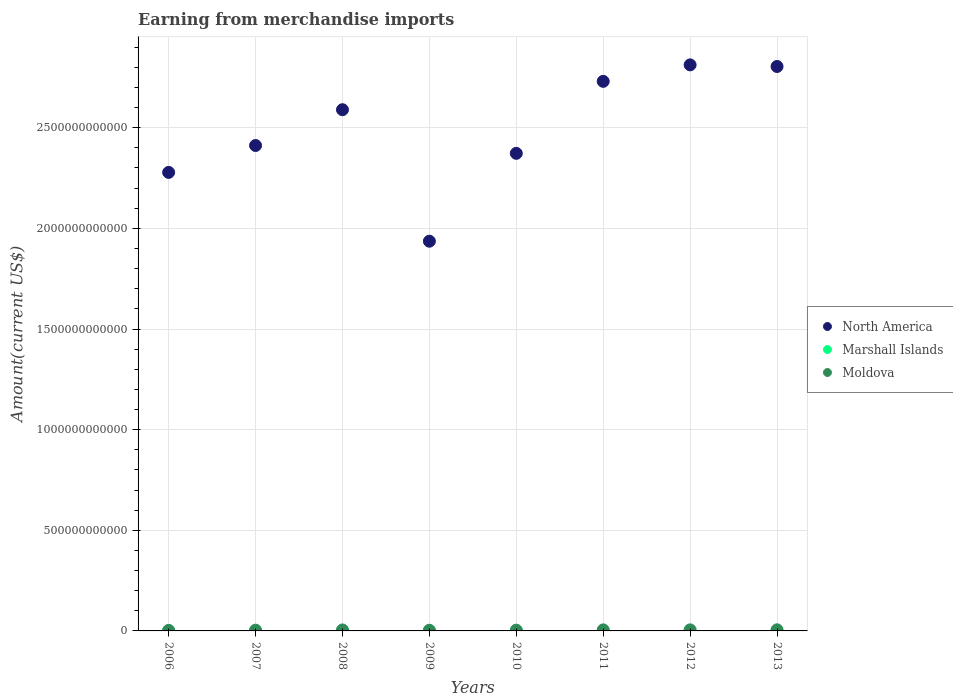What is the amount earned from merchandise imports in Moldova in 2008?
Your answer should be compact. 4.90e+09. Across all years, what is the maximum amount earned from merchandise imports in Marshall Islands?
Your answer should be compact. 1.50e+08. Across all years, what is the minimum amount earned from merchandise imports in Moldova?
Ensure brevity in your answer.  2.69e+09. What is the total amount earned from merchandise imports in Marshall Islands in the graph?
Your response must be concise. 9.56e+08. What is the difference between the amount earned from merchandise imports in Marshall Islands in 2006 and that in 2007?
Make the answer very short. -9.00e+06. What is the difference between the amount earned from merchandise imports in North America in 2010 and the amount earned from merchandise imports in Moldova in 2008?
Offer a terse response. 2.37e+12. What is the average amount earned from merchandise imports in Marshall Islands per year?
Keep it short and to the point. 1.20e+08. In the year 2009, what is the difference between the amount earned from merchandise imports in North America and amount earned from merchandise imports in Marshall Islands?
Offer a very short reply. 1.94e+12. What is the ratio of the amount earned from merchandise imports in North America in 2012 to that in 2013?
Your response must be concise. 1. Is the amount earned from merchandise imports in Marshall Islands in 2007 less than that in 2010?
Your answer should be very brief. Yes. What is the difference between the highest and the second highest amount earned from merchandise imports in North America?
Ensure brevity in your answer.  7.99e+09. What is the difference between the highest and the lowest amount earned from merchandise imports in Moldova?
Your response must be concise. 2.80e+09. Is it the case that in every year, the sum of the amount earned from merchandise imports in North America and amount earned from merchandise imports in Moldova  is greater than the amount earned from merchandise imports in Marshall Islands?
Your answer should be compact. Yes. Is the amount earned from merchandise imports in Moldova strictly greater than the amount earned from merchandise imports in North America over the years?
Ensure brevity in your answer.  No. Is the amount earned from merchandise imports in Moldova strictly less than the amount earned from merchandise imports in North America over the years?
Ensure brevity in your answer.  Yes. How many dotlines are there?
Offer a very short reply. 3. What is the difference between two consecutive major ticks on the Y-axis?
Ensure brevity in your answer.  5.00e+11. Does the graph contain any zero values?
Your answer should be very brief. No. Does the graph contain grids?
Offer a terse response. Yes. Where does the legend appear in the graph?
Ensure brevity in your answer.  Center right. How many legend labels are there?
Keep it short and to the point. 3. How are the legend labels stacked?
Give a very brief answer. Vertical. What is the title of the graph?
Make the answer very short. Earning from merchandise imports. Does "Italy" appear as one of the legend labels in the graph?
Offer a very short reply. No. What is the label or title of the X-axis?
Provide a short and direct response. Years. What is the label or title of the Y-axis?
Your answer should be very brief. Amount(current US$). What is the Amount(current US$) of North America in 2006?
Provide a short and direct response. 2.28e+12. What is the Amount(current US$) in Marshall Islands in 2006?
Provide a short and direct response. 9.10e+07. What is the Amount(current US$) in Moldova in 2006?
Keep it short and to the point. 2.69e+09. What is the Amount(current US$) of North America in 2007?
Your answer should be very brief. 2.41e+12. What is the Amount(current US$) of Marshall Islands in 2007?
Ensure brevity in your answer.  1.00e+08. What is the Amount(current US$) of Moldova in 2007?
Make the answer very short. 3.69e+09. What is the Amount(current US$) of North America in 2008?
Provide a short and direct response. 2.59e+12. What is the Amount(current US$) in Moldova in 2008?
Provide a short and direct response. 4.90e+09. What is the Amount(current US$) of North America in 2009?
Your response must be concise. 1.94e+12. What is the Amount(current US$) in Marshall Islands in 2009?
Your answer should be compact. 1.05e+08. What is the Amount(current US$) of Moldova in 2009?
Give a very brief answer. 3.28e+09. What is the Amount(current US$) in North America in 2010?
Provide a short and direct response. 2.37e+12. What is the Amount(current US$) in Marshall Islands in 2010?
Your answer should be very brief. 1.50e+08. What is the Amount(current US$) of Moldova in 2010?
Provide a short and direct response. 3.86e+09. What is the Amount(current US$) in North America in 2011?
Provide a short and direct response. 2.73e+12. What is the Amount(current US$) of Marshall Islands in 2011?
Keep it short and to the point. 1.30e+08. What is the Amount(current US$) of Moldova in 2011?
Make the answer very short. 5.19e+09. What is the Amount(current US$) in North America in 2012?
Offer a terse response. 2.81e+12. What is the Amount(current US$) of Marshall Islands in 2012?
Provide a short and direct response. 1.40e+08. What is the Amount(current US$) of Moldova in 2012?
Provide a succinct answer. 5.21e+09. What is the Amount(current US$) of North America in 2013?
Offer a very short reply. 2.80e+12. What is the Amount(current US$) in Marshall Islands in 2013?
Offer a very short reply. 1.40e+08. What is the Amount(current US$) in Moldova in 2013?
Provide a short and direct response. 5.49e+09. Across all years, what is the maximum Amount(current US$) in North America?
Offer a terse response. 2.81e+12. Across all years, what is the maximum Amount(current US$) of Marshall Islands?
Keep it short and to the point. 1.50e+08. Across all years, what is the maximum Amount(current US$) of Moldova?
Ensure brevity in your answer.  5.49e+09. Across all years, what is the minimum Amount(current US$) of North America?
Your response must be concise. 1.94e+12. Across all years, what is the minimum Amount(current US$) of Marshall Islands?
Provide a short and direct response. 9.10e+07. Across all years, what is the minimum Amount(current US$) of Moldova?
Offer a very short reply. 2.69e+09. What is the total Amount(current US$) of North America in the graph?
Provide a short and direct response. 1.99e+13. What is the total Amount(current US$) in Marshall Islands in the graph?
Make the answer very short. 9.56e+08. What is the total Amount(current US$) of Moldova in the graph?
Your response must be concise. 3.43e+1. What is the difference between the Amount(current US$) of North America in 2006 and that in 2007?
Your answer should be very brief. -1.34e+11. What is the difference between the Amount(current US$) in Marshall Islands in 2006 and that in 2007?
Make the answer very short. -9.00e+06. What is the difference between the Amount(current US$) in Moldova in 2006 and that in 2007?
Make the answer very short. -9.97e+08. What is the difference between the Amount(current US$) in North America in 2006 and that in 2008?
Your answer should be very brief. -3.11e+11. What is the difference between the Amount(current US$) of Marshall Islands in 2006 and that in 2008?
Offer a very short reply. -9.00e+06. What is the difference between the Amount(current US$) in Moldova in 2006 and that in 2008?
Make the answer very short. -2.21e+09. What is the difference between the Amount(current US$) in North America in 2006 and that in 2009?
Offer a terse response. 3.42e+11. What is the difference between the Amount(current US$) in Marshall Islands in 2006 and that in 2009?
Your response must be concise. -1.40e+07. What is the difference between the Amount(current US$) of Moldova in 2006 and that in 2009?
Give a very brief answer. -5.85e+08. What is the difference between the Amount(current US$) of North America in 2006 and that in 2010?
Your answer should be very brief. -9.47e+1. What is the difference between the Amount(current US$) in Marshall Islands in 2006 and that in 2010?
Provide a succinct answer. -5.90e+07. What is the difference between the Amount(current US$) in Moldova in 2006 and that in 2010?
Provide a short and direct response. -1.16e+09. What is the difference between the Amount(current US$) in North America in 2006 and that in 2011?
Offer a terse response. -4.52e+11. What is the difference between the Amount(current US$) of Marshall Islands in 2006 and that in 2011?
Offer a terse response. -3.90e+07. What is the difference between the Amount(current US$) of Moldova in 2006 and that in 2011?
Ensure brevity in your answer.  -2.50e+09. What is the difference between the Amount(current US$) of North America in 2006 and that in 2012?
Keep it short and to the point. -5.34e+11. What is the difference between the Amount(current US$) of Marshall Islands in 2006 and that in 2012?
Make the answer very short. -4.90e+07. What is the difference between the Amount(current US$) of Moldova in 2006 and that in 2012?
Offer a very short reply. -2.52e+09. What is the difference between the Amount(current US$) in North America in 2006 and that in 2013?
Offer a very short reply. -5.26e+11. What is the difference between the Amount(current US$) of Marshall Islands in 2006 and that in 2013?
Keep it short and to the point. -4.90e+07. What is the difference between the Amount(current US$) in Moldova in 2006 and that in 2013?
Your response must be concise. -2.80e+09. What is the difference between the Amount(current US$) of North America in 2007 and that in 2008?
Provide a succinct answer. -1.78e+11. What is the difference between the Amount(current US$) of Marshall Islands in 2007 and that in 2008?
Your response must be concise. 0. What is the difference between the Amount(current US$) of Moldova in 2007 and that in 2008?
Provide a short and direct response. -1.21e+09. What is the difference between the Amount(current US$) of North America in 2007 and that in 2009?
Your answer should be very brief. 4.75e+11. What is the difference between the Amount(current US$) in Marshall Islands in 2007 and that in 2009?
Give a very brief answer. -5.00e+06. What is the difference between the Amount(current US$) of Moldova in 2007 and that in 2009?
Your answer should be very brief. 4.12e+08. What is the difference between the Amount(current US$) of North America in 2007 and that in 2010?
Provide a short and direct response. 3.89e+1. What is the difference between the Amount(current US$) in Marshall Islands in 2007 and that in 2010?
Provide a succinct answer. -5.00e+07. What is the difference between the Amount(current US$) of Moldova in 2007 and that in 2010?
Offer a very short reply. -1.65e+08. What is the difference between the Amount(current US$) of North America in 2007 and that in 2011?
Make the answer very short. -3.19e+11. What is the difference between the Amount(current US$) in Marshall Islands in 2007 and that in 2011?
Offer a terse response. -3.00e+07. What is the difference between the Amount(current US$) of Moldova in 2007 and that in 2011?
Give a very brief answer. -1.50e+09. What is the difference between the Amount(current US$) of North America in 2007 and that in 2012?
Provide a short and direct response. -4.01e+11. What is the difference between the Amount(current US$) of Marshall Islands in 2007 and that in 2012?
Keep it short and to the point. -4.00e+07. What is the difference between the Amount(current US$) in Moldova in 2007 and that in 2012?
Offer a very short reply. -1.52e+09. What is the difference between the Amount(current US$) in North America in 2007 and that in 2013?
Keep it short and to the point. -3.93e+11. What is the difference between the Amount(current US$) of Marshall Islands in 2007 and that in 2013?
Make the answer very short. -4.00e+07. What is the difference between the Amount(current US$) of Moldova in 2007 and that in 2013?
Provide a succinct answer. -1.80e+09. What is the difference between the Amount(current US$) in North America in 2008 and that in 2009?
Your answer should be compact. 6.53e+11. What is the difference between the Amount(current US$) of Marshall Islands in 2008 and that in 2009?
Keep it short and to the point. -5.00e+06. What is the difference between the Amount(current US$) of Moldova in 2008 and that in 2009?
Offer a very short reply. 1.62e+09. What is the difference between the Amount(current US$) in North America in 2008 and that in 2010?
Your answer should be very brief. 2.17e+11. What is the difference between the Amount(current US$) of Marshall Islands in 2008 and that in 2010?
Offer a very short reply. -5.00e+07. What is the difference between the Amount(current US$) of Moldova in 2008 and that in 2010?
Give a very brief answer. 1.04e+09. What is the difference between the Amount(current US$) in North America in 2008 and that in 2011?
Keep it short and to the point. -1.41e+11. What is the difference between the Amount(current US$) in Marshall Islands in 2008 and that in 2011?
Provide a short and direct response. -3.00e+07. What is the difference between the Amount(current US$) in Moldova in 2008 and that in 2011?
Keep it short and to the point. -2.93e+08. What is the difference between the Amount(current US$) of North America in 2008 and that in 2012?
Give a very brief answer. -2.23e+11. What is the difference between the Amount(current US$) of Marshall Islands in 2008 and that in 2012?
Give a very brief answer. -4.00e+07. What is the difference between the Amount(current US$) of Moldova in 2008 and that in 2012?
Your answer should be compact. -3.14e+08. What is the difference between the Amount(current US$) in North America in 2008 and that in 2013?
Your answer should be compact. -2.15e+11. What is the difference between the Amount(current US$) of Marshall Islands in 2008 and that in 2013?
Your response must be concise. -4.00e+07. What is the difference between the Amount(current US$) in Moldova in 2008 and that in 2013?
Provide a succinct answer. -5.94e+08. What is the difference between the Amount(current US$) of North America in 2009 and that in 2010?
Offer a very short reply. -4.37e+11. What is the difference between the Amount(current US$) in Marshall Islands in 2009 and that in 2010?
Ensure brevity in your answer.  -4.50e+07. What is the difference between the Amount(current US$) of Moldova in 2009 and that in 2010?
Your answer should be very brief. -5.77e+08. What is the difference between the Amount(current US$) in North America in 2009 and that in 2011?
Offer a terse response. -7.94e+11. What is the difference between the Amount(current US$) of Marshall Islands in 2009 and that in 2011?
Offer a very short reply. -2.50e+07. What is the difference between the Amount(current US$) in Moldova in 2009 and that in 2011?
Your response must be concise. -1.91e+09. What is the difference between the Amount(current US$) of North America in 2009 and that in 2012?
Make the answer very short. -8.76e+11. What is the difference between the Amount(current US$) in Marshall Islands in 2009 and that in 2012?
Offer a terse response. -3.50e+07. What is the difference between the Amount(current US$) of Moldova in 2009 and that in 2012?
Keep it short and to the point. -1.93e+09. What is the difference between the Amount(current US$) of North America in 2009 and that in 2013?
Provide a succinct answer. -8.68e+11. What is the difference between the Amount(current US$) in Marshall Islands in 2009 and that in 2013?
Your response must be concise. -3.50e+07. What is the difference between the Amount(current US$) of Moldova in 2009 and that in 2013?
Your response must be concise. -2.21e+09. What is the difference between the Amount(current US$) of North America in 2010 and that in 2011?
Keep it short and to the point. -3.58e+11. What is the difference between the Amount(current US$) of Moldova in 2010 and that in 2011?
Your response must be concise. -1.34e+09. What is the difference between the Amount(current US$) in North America in 2010 and that in 2012?
Offer a terse response. -4.40e+11. What is the difference between the Amount(current US$) in Marshall Islands in 2010 and that in 2012?
Offer a very short reply. 1.00e+07. What is the difference between the Amount(current US$) of Moldova in 2010 and that in 2012?
Make the answer very short. -1.36e+09. What is the difference between the Amount(current US$) in North America in 2010 and that in 2013?
Your answer should be very brief. -4.32e+11. What is the difference between the Amount(current US$) of Moldova in 2010 and that in 2013?
Keep it short and to the point. -1.64e+09. What is the difference between the Amount(current US$) in North America in 2011 and that in 2012?
Provide a succinct answer. -8.18e+1. What is the difference between the Amount(current US$) of Marshall Islands in 2011 and that in 2012?
Your response must be concise. -1.00e+07. What is the difference between the Amount(current US$) of Moldova in 2011 and that in 2012?
Provide a succinct answer. -2.16e+07. What is the difference between the Amount(current US$) of North America in 2011 and that in 2013?
Provide a succinct answer. -7.38e+1. What is the difference between the Amount(current US$) of Marshall Islands in 2011 and that in 2013?
Your response must be concise. -1.00e+07. What is the difference between the Amount(current US$) of Moldova in 2011 and that in 2013?
Ensure brevity in your answer.  -3.01e+08. What is the difference between the Amount(current US$) of North America in 2012 and that in 2013?
Your answer should be very brief. 7.99e+09. What is the difference between the Amount(current US$) of Marshall Islands in 2012 and that in 2013?
Offer a terse response. 0. What is the difference between the Amount(current US$) of Moldova in 2012 and that in 2013?
Offer a very short reply. -2.80e+08. What is the difference between the Amount(current US$) in North America in 2006 and the Amount(current US$) in Marshall Islands in 2007?
Offer a terse response. 2.28e+12. What is the difference between the Amount(current US$) of North America in 2006 and the Amount(current US$) of Moldova in 2007?
Your answer should be very brief. 2.27e+12. What is the difference between the Amount(current US$) of Marshall Islands in 2006 and the Amount(current US$) of Moldova in 2007?
Provide a short and direct response. -3.60e+09. What is the difference between the Amount(current US$) in North America in 2006 and the Amount(current US$) in Marshall Islands in 2008?
Your response must be concise. 2.28e+12. What is the difference between the Amount(current US$) of North America in 2006 and the Amount(current US$) of Moldova in 2008?
Your answer should be very brief. 2.27e+12. What is the difference between the Amount(current US$) in Marshall Islands in 2006 and the Amount(current US$) in Moldova in 2008?
Offer a terse response. -4.81e+09. What is the difference between the Amount(current US$) of North America in 2006 and the Amount(current US$) of Marshall Islands in 2009?
Offer a terse response. 2.28e+12. What is the difference between the Amount(current US$) in North America in 2006 and the Amount(current US$) in Moldova in 2009?
Your answer should be very brief. 2.27e+12. What is the difference between the Amount(current US$) in Marshall Islands in 2006 and the Amount(current US$) in Moldova in 2009?
Make the answer very short. -3.19e+09. What is the difference between the Amount(current US$) in North America in 2006 and the Amount(current US$) in Marshall Islands in 2010?
Offer a very short reply. 2.28e+12. What is the difference between the Amount(current US$) of North America in 2006 and the Amount(current US$) of Moldova in 2010?
Make the answer very short. 2.27e+12. What is the difference between the Amount(current US$) in Marshall Islands in 2006 and the Amount(current US$) in Moldova in 2010?
Make the answer very short. -3.76e+09. What is the difference between the Amount(current US$) in North America in 2006 and the Amount(current US$) in Marshall Islands in 2011?
Your answer should be compact. 2.28e+12. What is the difference between the Amount(current US$) in North America in 2006 and the Amount(current US$) in Moldova in 2011?
Ensure brevity in your answer.  2.27e+12. What is the difference between the Amount(current US$) in Marshall Islands in 2006 and the Amount(current US$) in Moldova in 2011?
Offer a terse response. -5.10e+09. What is the difference between the Amount(current US$) in North America in 2006 and the Amount(current US$) in Marshall Islands in 2012?
Provide a short and direct response. 2.28e+12. What is the difference between the Amount(current US$) in North America in 2006 and the Amount(current US$) in Moldova in 2012?
Your answer should be very brief. 2.27e+12. What is the difference between the Amount(current US$) in Marshall Islands in 2006 and the Amount(current US$) in Moldova in 2012?
Keep it short and to the point. -5.12e+09. What is the difference between the Amount(current US$) in North America in 2006 and the Amount(current US$) in Marshall Islands in 2013?
Offer a very short reply. 2.28e+12. What is the difference between the Amount(current US$) in North America in 2006 and the Amount(current US$) in Moldova in 2013?
Your response must be concise. 2.27e+12. What is the difference between the Amount(current US$) of Marshall Islands in 2006 and the Amount(current US$) of Moldova in 2013?
Make the answer very short. -5.40e+09. What is the difference between the Amount(current US$) in North America in 2007 and the Amount(current US$) in Marshall Islands in 2008?
Provide a short and direct response. 2.41e+12. What is the difference between the Amount(current US$) in North America in 2007 and the Amount(current US$) in Moldova in 2008?
Make the answer very short. 2.41e+12. What is the difference between the Amount(current US$) of Marshall Islands in 2007 and the Amount(current US$) of Moldova in 2008?
Your response must be concise. -4.80e+09. What is the difference between the Amount(current US$) in North America in 2007 and the Amount(current US$) in Marshall Islands in 2009?
Your answer should be very brief. 2.41e+12. What is the difference between the Amount(current US$) in North America in 2007 and the Amount(current US$) in Moldova in 2009?
Offer a terse response. 2.41e+12. What is the difference between the Amount(current US$) in Marshall Islands in 2007 and the Amount(current US$) in Moldova in 2009?
Your answer should be compact. -3.18e+09. What is the difference between the Amount(current US$) of North America in 2007 and the Amount(current US$) of Marshall Islands in 2010?
Make the answer very short. 2.41e+12. What is the difference between the Amount(current US$) of North America in 2007 and the Amount(current US$) of Moldova in 2010?
Keep it short and to the point. 2.41e+12. What is the difference between the Amount(current US$) of Marshall Islands in 2007 and the Amount(current US$) of Moldova in 2010?
Offer a terse response. -3.76e+09. What is the difference between the Amount(current US$) of North America in 2007 and the Amount(current US$) of Marshall Islands in 2011?
Give a very brief answer. 2.41e+12. What is the difference between the Amount(current US$) in North America in 2007 and the Amount(current US$) in Moldova in 2011?
Make the answer very short. 2.41e+12. What is the difference between the Amount(current US$) in Marshall Islands in 2007 and the Amount(current US$) in Moldova in 2011?
Provide a short and direct response. -5.09e+09. What is the difference between the Amount(current US$) of North America in 2007 and the Amount(current US$) of Marshall Islands in 2012?
Offer a very short reply. 2.41e+12. What is the difference between the Amount(current US$) in North America in 2007 and the Amount(current US$) in Moldova in 2012?
Give a very brief answer. 2.41e+12. What is the difference between the Amount(current US$) in Marshall Islands in 2007 and the Amount(current US$) in Moldova in 2012?
Offer a very short reply. -5.11e+09. What is the difference between the Amount(current US$) in North America in 2007 and the Amount(current US$) in Marshall Islands in 2013?
Offer a terse response. 2.41e+12. What is the difference between the Amount(current US$) of North America in 2007 and the Amount(current US$) of Moldova in 2013?
Keep it short and to the point. 2.41e+12. What is the difference between the Amount(current US$) of Marshall Islands in 2007 and the Amount(current US$) of Moldova in 2013?
Your response must be concise. -5.39e+09. What is the difference between the Amount(current US$) of North America in 2008 and the Amount(current US$) of Marshall Islands in 2009?
Provide a succinct answer. 2.59e+12. What is the difference between the Amount(current US$) in North America in 2008 and the Amount(current US$) in Moldova in 2009?
Your response must be concise. 2.59e+12. What is the difference between the Amount(current US$) in Marshall Islands in 2008 and the Amount(current US$) in Moldova in 2009?
Give a very brief answer. -3.18e+09. What is the difference between the Amount(current US$) of North America in 2008 and the Amount(current US$) of Marshall Islands in 2010?
Give a very brief answer. 2.59e+12. What is the difference between the Amount(current US$) of North America in 2008 and the Amount(current US$) of Moldova in 2010?
Provide a short and direct response. 2.59e+12. What is the difference between the Amount(current US$) in Marshall Islands in 2008 and the Amount(current US$) in Moldova in 2010?
Your answer should be compact. -3.76e+09. What is the difference between the Amount(current US$) of North America in 2008 and the Amount(current US$) of Marshall Islands in 2011?
Keep it short and to the point. 2.59e+12. What is the difference between the Amount(current US$) in North America in 2008 and the Amount(current US$) in Moldova in 2011?
Offer a very short reply. 2.58e+12. What is the difference between the Amount(current US$) in Marshall Islands in 2008 and the Amount(current US$) in Moldova in 2011?
Provide a short and direct response. -5.09e+09. What is the difference between the Amount(current US$) of North America in 2008 and the Amount(current US$) of Marshall Islands in 2012?
Keep it short and to the point. 2.59e+12. What is the difference between the Amount(current US$) in North America in 2008 and the Amount(current US$) in Moldova in 2012?
Provide a short and direct response. 2.58e+12. What is the difference between the Amount(current US$) of Marshall Islands in 2008 and the Amount(current US$) of Moldova in 2012?
Keep it short and to the point. -5.11e+09. What is the difference between the Amount(current US$) of North America in 2008 and the Amount(current US$) of Marshall Islands in 2013?
Give a very brief answer. 2.59e+12. What is the difference between the Amount(current US$) in North America in 2008 and the Amount(current US$) in Moldova in 2013?
Provide a short and direct response. 2.58e+12. What is the difference between the Amount(current US$) of Marshall Islands in 2008 and the Amount(current US$) of Moldova in 2013?
Give a very brief answer. -5.39e+09. What is the difference between the Amount(current US$) in North America in 2009 and the Amount(current US$) in Marshall Islands in 2010?
Give a very brief answer. 1.94e+12. What is the difference between the Amount(current US$) of North America in 2009 and the Amount(current US$) of Moldova in 2010?
Your response must be concise. 1.93e+12. What is the difference between the Amount(current US$) of Marshall Islands in 2009 and the Amount(current US$) of Moldova in 2010?
Provide a short and direct response. -3.75e+09. What is the difference between the Amount(current US$) of North America in 2009 and the Amount(current US$) of Marshall Islands in 2011?
Offer a very short reply. 1.94e+12. What is the difference between the Amount(current US$) in North America in 2009 and the Amount(current US$) in Moldova in 2011?
Keep it short and to the point. 1.93e+12. What is the difference between the Amount(current US$) in Marshall Islands in 2009 and the Amount(current US$) in Moldova in 2011?
Offer a very short reply. -5.09e+09. What is the difference between the Amount(current US$) in North America in 2009 and the Amount(current US$) in Marshall Islands in 2012?
Make the answer very short. 1.94e+12. What is the difference between the Amount(current US$) in North America in 2009 and the Amount(current US$) in Moldova in 2012?
Offer a terse response. 1.93e+12. What is the difference between the Amount(current US$) of Marshall Islands in 2009 and the Amount(current US$) of Moldova in 2012?
Provide a succinct answer. -5.11e+09. What is the difference between the Amount(current US$) of North America in 2009 and the Amount(current US$) of Marshall Islands in 2013?
Make the answer very short. 1.94e+12. What is the difference between the Amount(current US$) of North America in 2009 and the Amount(current US$) of Moldova in 2013?
Keep it short and to the point. 1.93e+12. What is the difference between the Amount(current US$) in Marshall Islands in 2009 and the Amount(current US$) in Moldova in 2013?
Provide a succinct answer. -5.39e+09. What is the difference between the Amount(current US$) of North America in 2010 and the Amount(current US$) of Marshall Islands in 2011?
Offer a terse response. 2.37e+12. What is the difference between the Amount(current US$) in North America in 2010 and the Amount(current US$) in Moldova in 2011?
Keep it short and to the point. 2.37e+12. What is the difference between the Amount(current US$) in Marshall Islands in 2010 and the Amount(current US$) in Moldova in 2011?
Keep it short and to the point. -5.04e+09. What is the difference between the Amount(current US$) of North America in 2010 and the Amount(current US$) of Marshall Islands in 2012?
Offer a terse response. 2.37e+12. What is the difference between the Amount(current US$) of North America in 2010 and the Amount(current US$) of Moldova in 2012?
Make the answer very short. 2.37e+12. What is the difference between the Amount(current US$) in Marshall Islands in 2010 and the Amount(current US$) in Moldova in 2012?
Your answer should be very brief. -5.06e+09. What is the difference between the Amount(current US$) of North America in 2010 and the Amount(current US$) of Marshall Islands in 2013?
Your answer should be compact. 2.37e+12. What is the difference between the Amount(current US$) in North America in 2010 and the Amount(current US$) in Moldova in 2013?
Make the answer very short. 2.37e+12. What is the difference between the Amount(current US$) of Marshall Islands in 2010 and the Amount(current US$) of Moldova in 2013?
Provide a short and direct response. -5.34e+09. What is the difference between the Amount(current US$) in North America in 2011 and the Amount(current US$) in Marshall Islands in 2012?
Provide a short and direct response. 2.73e+12. What is the difference between the Amount(current US$) in North America in 2011 and the Amount(current US$) in Moldova in 2012?
Offer a very short reply. 2.73e+12. What is the difference between the Amount(current US$) of Marshall Islands in 2011 and the Amount(current US$) of Moldova in 2012?
Your answer should be very brief. -5.08e+09. What is the difference between the Amount(current US$) of North America in 2011 and the Amount(current US$) of Marshall Islands in 2013?
Make the answer very short. 2.73e+12. What is the difference between the Amount(current US$) of North America in 2011 and the Amount(current US$) of Moldova in 2013?
Your answer should be very brief. 2.73e+12. What is the difference between the Amount(current US$) of Marshall Islands in 2011 and the Amount(current US$) of Moldova in 2013?
Your response must be concise. -5.36e+09. What is the difference between the Amount(current US$) of North America in 2012 and the Amount(current US$) of Marshall Islands in 2013?
Make the answer very short. 2.81e+12. What is the difference between the Amount(current US$) of North America in 2012 and the Amount(current US$) of Moldova in 2013?
Ensure brevity in your answer.  2.81e+12. What is the difference between the Amount(current US$) in Marshall Islands in 2012 and the Amount(current US$) in Moldova in 2013?
Provide a short and direct response. -5.35e+09. What is the average Amount(current US$) in North America per year?
Offer a terse response. 2.49e+12. What is the average Amount(current US$) of Marshall Islands per year?
Provide a succinct answer. 1.20e+08. What is the average Amount(current US$) of Moldova per year?
Your answer should be very brief. 4.29e+09. In the year 2006, what is the difference between the Amount(current US$) of North America and Amount(current US$) of Marshall Islands?
Offer a terse response. 2.28e+12. In the year 2006, what is the difference between the Amount(current US$) of North America and Amount(current US$) of Moldova?
Offer a terse response. 2.28e+12. In the year 2006, what is the difference between the Amount(current US$) of Marshall Islands and Amount(current US$) of Moldova?
Offer a very short reply. -2.60e+09. In the year 2007, what is the difference between the Amount(current US$) of North America and Amount(current US$) of Marshall Islands?
Provide a short and direct response. 2.41e+12. In the year 2007, what is the difference between the Amount(current US$) in North America and Amount(current US$) in Moldova?
Ensure brevity in your answer.  2.41e+12. In the year 2007, what is the difference between the Amount(current US$) in Marshall Islands and Amount(current US$) in Moldova?
Provide a short and direct response. -3.59e+09. In the year 2008, what is the difference between the Amount(current US$) in North America and Amount(current US$) in Marshall Islands?
Provide a succinct answer. 2.59e+12. In the year 2008, what is the difference between the Amount(current US$) of North America and Amount(current US$) of Moldova?
Provide a succinct answer. 2.58e+12. In the year 2008, what is the difference between the Amount(current US$) of Marshall Islands and Amount(current US$) of Moldova?
Your response must be concise. -4.80e+09. In the year 2009, what is the difference between the Amount(current US$) in North America and Amount(current US$) in Marshall Islands?
Make the answer very short. 1.94e+12. In the year 2009, what is the difference between the Amount(current US$) of North America and Amount(current US$) of Moldova?
Your answer should be compact. 1.93e+12. In the year 2009, what is the difference between the Amount(current US$) of Marshall Islands and Amount(current US$) of Moldova?
Your answer should be very brief. -3.17e+09. In the year 2010, what is the difference between the Amount(current US$) of North America and Amount(current US$) of Marshall Islands?
Offer a very short reply. 2.37e+12. In the year 2010, what is the difference between the Amount(current US$) of North America and Amount(current US$) of Moldova?
Offer a terse response. 2.37e+12. In the year 2010, what is the difference between the Amount(current US$) of Marshall Islands and Amount(current US$) of Moldova?
Ensure brevity in your answer.  -3.71e+09. In the year 2011, what is the difference between the Amount(current US$) in North America and Amount(current US$) in Marshall Islands?
Keep it short and to the point. 2.73e+12. In the year 2011, what is the difference between the Amount(current US$) in North America and Amount(current US$) in Moldova?
Provide a succinct answer. 2.73e+12. In the year 2011, what is the difference between the Amount(current US$) of Marshall Islands and Amount(current US$) of Moldova?
Make the answer very short. -5.06e+09. In the year 2012, what is the difference between the Amount(current US$) of North America and Amount(current US$) of Marshall Islands?
Provide a succinct answer. 2.81e+12. In the year 2012, what is the difference between the Amount(current US$) of North America and Amount(current US$) of Moldova?
Ensure brevity in your answer.  2.81e+12. In the year 2012, what is the difference between the Amount(current US$) in Marshall Islands and Amount(current US$) in Moldova?
Keep it short and to the point. -5.07e+09. In the year 2013, what is the difference between the Amount(current US$) in North America and Amount(current US$) in Marshall Islands?
Ensure brevity in your answer.  2.80e+12. In the year 2013, what is the difference between the Amount(current US$) of North America and Amount(current US$) of Moldova?
Offer a terse response. 2.80e+12. In the year 2013, what is the difference between the Amount(current US$) in Marshall Islands and Amount(current US$) in Moldova?
Keep it short and to the point. -5.35e+09. What is the ratio of the Amount(current US$) in North America in 2006 to that in 2007?
Keep it short and to the point. 0.94. What is the ratio of the Amount(current US$) in Marshall Islands in 2006 to that in 2007?
Give a very brief answer. 0.91. What is the ratio of the Amount(current US$) in Moldova in 2006 to that in 2007?
Provide a short and direct response. 0.73. What is the ratio of the Amount(current US$) of North America in 2006 to that in 2008?
Offer a terse response. 0.88. What is the ratio of the Amount(current US$) of Marshall Islands in 2006 to that in 2008?
Keep it short and to the point. 0.91. What is the ratio of the Amount(current US$) in Moldova in 2006 to that in 2008?
Make the answer very short. 0.55. What is the ratio of the Amount(current US$) in North America in 2006 to that in 2009?
Ensure brevity in your answer.  1.18. What is the ratio of the Amount(current US$) of Marshall Islands in 2006 to that in 2009?
Make the answer very short. 0.87. What is the ratio of the Amount(current US$) of Moldova in 2006 to that in 2009?
Provide a succinct answer. 0.82. What is the ratio of the Amount(current US$) of North America in 2006 to that in 2010?
Your answer should be very brief. 0.96. What is the ratio of the Amount(current US$) of Marshall Islands in 2006 to that in 2010?
Your answer should be very brief. 0.61. What is the ratio of the Amount(current US$) of Moldova in 2006 to that in 2010?
Provide a short and direct response. 0.7. What is the ratio of the Amount(current US$) in North America in 2006 to that in 2011?
Make the answer very short. 0.83. What is the ratio of the Amount(current US$) in Marshall Islands in 2006 to that in 2011?
Make the answer very short. 0.7. What is the ratio of the Amount(current US$) in Moldova in 2006 to that in 2011?
Your response must be concise. 0.52. What is the ratio of the Amount(current US$) in North America in 2006 to that in 2012?
Offer a very short reply. 0.81. What is the ratio of the Amount(current US$) of Marshall Islands in 2006 to that in 2012?
Make the answer very short. 0.65. What is the ratio of the Amount(current US$) of Moldova in 2006 to that in 2012?
Provide a succinct answer. 0.52. What is the ratio of the Amount(current US$) in North America in 2006 to that in 2013?
Offer a terse response. 0.81. What is the ratio of the Amount(current US$) in Marshall Islands in 2006 to that in 2013?
Your response must be concise. 0.65. What is the ratio of the Amount(current US$) in Moldova in 2006 to that in 2013?
Make the answer very short. 0.49. What is the ratio of the Amount(current US$) of North America in 2007 to that in 2008?
Give a very brief answer. 0.93. What is the ratio of the Amount(current US$) of Marshall Islands in 2007 to that in 2008?
Your answer should be compact. 1. What is the ratio of the Amount(current US$) of Moldova in 2007 to that in 2008?
Provide a short and direct response. 0.75. What is the ratio of the Amount(current US$) in North America in 2007 to that in 2009?
Make the answer very short. 1.25. What is the ratio of the Amount(current US$) in Moldova in 2007 to that in 2009?
Make the answer very short. 1.13. What is the ratio of the Amount(current US$) of North America in 2007 to that in 2010?
Offer a terse response. 1.02. What is the ratio of the Amount(current US$) in Marshall Islands in 2007 to that in 2010?
Your answer should be compact. 0.67. What is the ratio of the Amount(current US$) in Moldova in 2007 to that in 2010?
Offer a terse response. 0.96. What is the ratio of the Amount(current US$) in North America in 2007 to that in 2011?
Provide a short and direct response. 0.88. What is the ratio of the Amount(current US$) in Marshall Islands in 2007 to that in 2011?
Provide a succinct answer. 0.77. What is the ratio of the Amount(current US$) of Moldova in 2007 to that in 2011?
Provide a short and direct response. 0.71. What is the ratio of the Amount(current US$) in North America in 2007 to that in 2012?
Your answer should be very brief. 0.86. What is the ratio of the Amount(current US$) in Moldova in 2007 to that in 2012?
Give a very brief answer. 0.71. What is the ratio of the Amount(current US$) of North America in 2007 to that in 2013?
Your answer should be compact. 0.86. What is the ratio of the Amount(current US$) in Moldova in 2007 to that in 2013?
Offer a very short reply. 0.67. What is the ratio of the Amount(current US$) of North America in 2008 to that in 2009?
Your answer should be very brief. 1.34. What is the ratio of the Amount(current US$) of Moldova in 2008 to that in 2009?
Provide a short and direct response. 1.49. What is the ratio of the Amount(current US$) of North America in 2008 to that in 2010?
Ensure brevity in your answer.  1.09. What is the ratio of the Amount(current US$) of Marshall Islands in 2008 to that in 2010?
Offer a very short reply. 0.67. What is the ratio of the Amount(current US$) of Moldova in 2008 to that in 2010?
Provide a succinct answer. 1.27. What is the ratio of the Amount(current US$) of North America in 2008 to that in 2011?
Your answer should be compact. 0.95. What is the ratio of the Amount(current US$) of Marshall Islands in 2008 to that in 2011?
Provide a succinct answer. 0.77. What is the ratio of the Amount(current US$) of Moldova in 2008 to that in 2011?
Make the answer very short. 0.94. What is the ratio of the Amount(current US$) in North America in 2008 to that in 2012?
Offer a very short reply. 0.92. What is the ratio of the Amount(current US$) of Marshall Islands in 2008 to that in 2012?
Keep it short and to the point. 0.71. What is the ratio of the Amount(current US$) of Moldova in 2008 to that in 2012?
Ensure brevity in your answer.  0.94. What is the ratio of the Amount(current US$) of North America in 2008 to that in 2013?
Offer a terse response. 0.92. What is the ratio of the Amount(current US$) in Moldova in 2008 to that in 2013?
Keep it short and to the point. 0.89. What is the ratio of the Amount(current US$) of North America in 2009 to that in 2010?
Provide a succinct answer. 0.82. What is the ratio of the Amount(current US$) of Moldova in 2009 to that in 2010?
Offer a terse response. 0.85. What is the ratio of the Amount(current US$) of North America in 2009 to that in 2011?
Make the answer very short. 0.71. What is the ratio of the Amount(current US$) of Marshall Islands in 2009 to that in 2011?
Make the answer very short. 0.81. What is the ratio of the Amount(current US$) in Moldova in 2009 to that in 2011?
Make the answer very short. 0.63. What is the ratio of the Amount(current US$) of North America in 2009 to that in 2012?
Offer a terse response. 0.69. What is the ratio of the Amount(current US$) of Marshall Islands in 2009 to that in 2012?
Your answer should be very brief. 0.75. What is the ratio of the Amount(current US$) of Moldova in 2009 to that in 2012?
Your answer should be compact. 0.63. What is the ratio of the Amount(current US$) in North America in 2009 to that in 2013?
Your response must be concise. 0.69. What is the ratio of the Amount(current US$) in Marshall Islands in 2009 to that in 2013?
Your answer should be very brief. 0.75. What is the ratio of the Amount(current US$) of Moldova in 2009 to that in 2013?
Offer a very short reply. 0.6. What is the ratio of the Amount(current US$) in North America in 2010 to that in 2011?
Provide a short and direct response. 0.87. What is the ratio of the Amount(current US$) of Marshall Islands in 2010 to that in 2011?
Make the answer very short. 1.15. What is the ratio of the Amount(current US$) in Moldova in 2010 to that in 2011?
Ensure brevity in your answer.  0.74. What is the ratio of the Amount(current US$) in North America in 2010 to that in 2012?
Your answer should be compact. 0.84. What is the ratio of the Amount(current US$) of Marshall Islands in 2010 to that in 2012?
Your answer should be compact. 1.07. What is the ratio of the Amount(current US$) in Moldova in 2010 to that in 2012?
Provide a short and direct response. 0.74. What is the ratio of the Amount(current US$) of North America in 2010 to that in 2013?
Offer a terse response. 0.85. What is the ratio of the Amount(current US$) in Marshall Islands in 2010 to that in 2013?
Your answer should be very brief. 1.07. What is the ratio of the Amount(current US$) of Moldova in 2010 to that in 2013?
Your answer should be very brief. 0.7. What is the ratio of the Amount(current US$) of North America in 2011 to that in 2012?
Your answer should be very brief. 0.97. What is the ratio of the Amount(current US$) in Marshall Islands in 2011 to that in 2012?
Provide a short and direct response. 0.93. What is the ratio of the Amount(current US$) of Moldova in 2011 to that in 2012?
Your answer should be compact. 1. What is the ratio of the Amount(current US$) of North America in 2011 to that in 2013?
Provide a succinct answer. 0.97. What is the ratio of the Amount(current US$) in Moldova in 2011 to that in 2013?
Provide a succinct answer. 0.95. What is the ratio of the Amount(current US$) in Moldova in 2012 to that in 2013?
Provide a short and direct response. 0.95. What is the difference between the highest and the second highest Amount(current US$) of North America?
Keep it short and to the point. 7.99e+09. What is the difference between the highest and the second highest Amount(current US$) of Marshall Islands?
Give a very brief answer. 1.00e+07. What is the difference between the highest and the second highest Amount(current US$) of Moldova?
Keep it short and to the point. 2.80e+08. What is the difference between the highest and the lowest Amount(current US$) in North America?
Your response must be concise. 8.76e+11. What is the difference between the highest and the lowest Amount(current US$) of Marshall Islands?
Give a very brief answer. 5.90e+07. What is the difference between the highest and the lowest Amount(current US$) in Moldova?
Your response must be concise. 2.80e+09. 